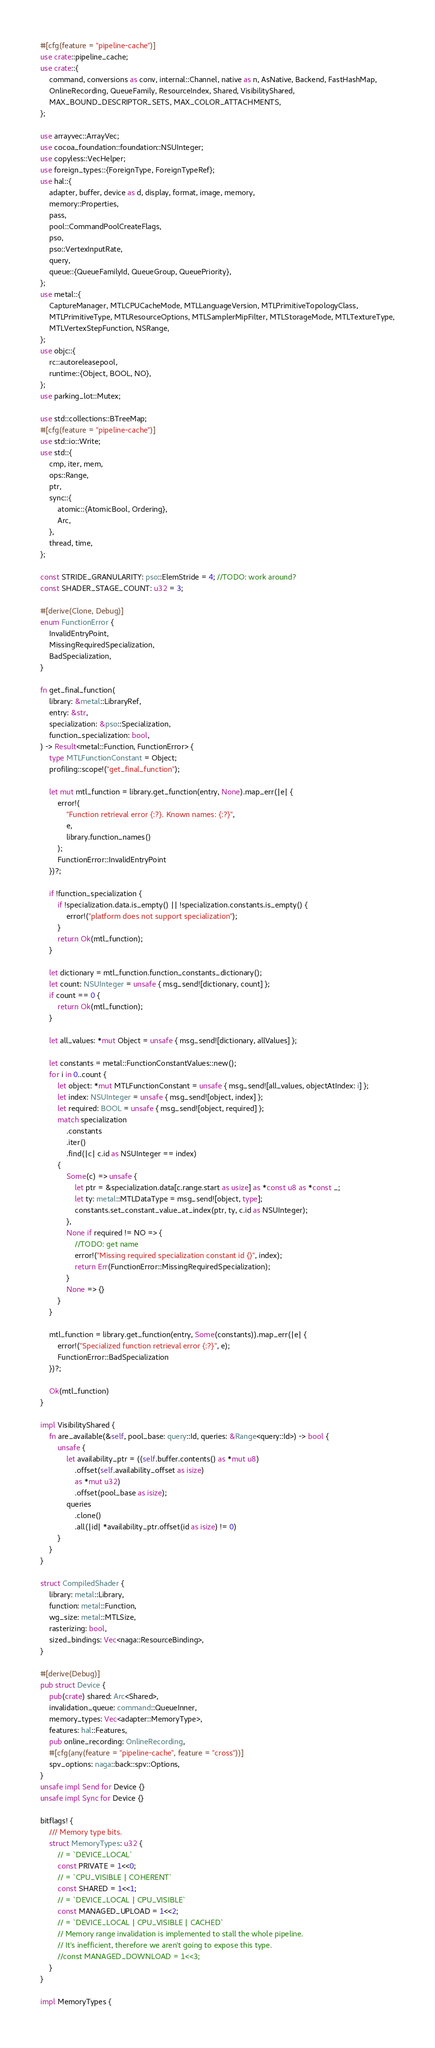Convert code to text. <code><loc_0><loc_0><loc_500><loc_500><_Rust_>#[cfg(feature = "pipeline-cache")]
use crate::pipeline_cache;
use crate::{
    command, conversions as conv, internal::Channel, native as n, AsNative, Backend, FastHashMap,
    OnlineRecording, QueueFamily, ResourceIndex, Shared, VisibilityShared,
    MAX_BOUND_DESCRIPTOR_SETS, MAX_COLOR_ATTACHMENTS,
};

use arrayvec::ArrayVec;
use cocoa_foundation::foundation::NSUInteger;
use copyless::VecHelper;
use foreign_types::{ForeignType, ForeignTypeRef};
use hal::{
    adapter, buffer, device as d, display, format, image, memory,
    memory::Properties,
    pass,
    pool::CommandPoolCreateFlags,
    pso,
    pso::VertexInputRate,
    query,
    queue::{QueueFamilyId, QueueGroup, QueuePriority},
};
use metal::{
    CaptureManager, MTLCPUCacheMode, MTLLanguageVersion, MTLPrimitiveTopologyClass,
    MTLPrimitiveType, MTLResourceOptions, MTLSamplerMipFilter, MTLStorageMode, MTLTextureType,
    MTLVertexStepFunction, NSRange,
};
use objc::{
    rc::autoreleasepool,
    runtime::{Object, BOOL, NO},
};
use parking_lot::Mutex;

use std::collections::BTreeMap;
#[cfg(feature = "pipeline-cache")]
use std::io::Write;
use std::{
    cmp, iter, mem,
    ops::Range,
    ptr,
    sync::{
        atomic::{AtomicBool, Ordering},
        Arc,
    },
    thread, time,
};

const STRIDE_GRANULARITY: pso::ElemStride = 4; //TODO: work around?
const SHADER_STAGE_COUNT: u32 = 3;

#[derive(Clone, Debug)]
enum FunctionError {
    InvalidEntryPoint,
    MissingRequiredSpecialization,
    BadSpecialization,
}

fn get_final_function(
    library: &metal::LibraryRef,
    entry: &str,
    specialization: &pso::Specialization,
    function_specialization: bool,
) -> Result<metal::Function, FunctionError> {
    type MTLFunctionConstant = Object;
    profiling::scope!("get_final_function");

    let mut mtl_function = library.get_function(entry, None).map_err(|e| {
        error!(
            "Function retrieval error {:?}. Known names: {:?}",
            e,
            library.function_names()
        );
        FunctionError::InvalidEntryPoint
    })?;

    if !function_specialization {
        if !specialization.data.is_empty() || !specialization.constants.is_empty() {
            error!("platform does not support specialization");
        }
        return Ok(mtl_function);
    }

    let dictionary = mtl_function.function_constants_dictionary();
    let count: NSUInteger = unsafe { msg_send![dictionary, count] };
    if count == 0 {
        return Ok(mtl_function);
    }

    let all_values: *mut Object = unsafe { msg_send![dictionary, allValues] };

    let constants = metal::FunctionConstantValues::new();
    for i in 0..count {
        let object: *mut MTLFunctionConstant = unsafe { msg_send![all_values, objectAtIndex: i] };
        let index: NSUInteger = unsafe { msg_send![object, index] };
        let required: BOOL = unsafe { msg_send![object, required] };
        match specialization
            .constants
            .iter()
            .find(|c| c.id as NSUInteger == index)
        {
            Some(c) => unsafe {
                let ptr = &specialization.data[c.range.start as usize] as *const u8 as *const _;
                let ty: metal::MTLDataType = msg_send![object, type];
                constants.set_constant_value_at_index(ptr, ty, c.id as NSUInteger);
            },
            None if required != NO => {
                //TODO: get name
                error!("Missing required specialization constant id {}", index);
                return Err(FunctionError::MissingRequiredSpecialization);
            }
            None => {}
        }
    }

    mtl_function = library.get_function(entry, Some(constants)).map_err(|e| {
        error!("Specialized function retrieval error {:?}", e);
        FunctionError::BadSpecialization
    })?;

    Ok(mtl_function)
}

impl VisibilityShared {
    fn are_available(&self, pool_base: query::Id, queries: &Range<query::Id>) -> bool {
        unsafe {
            let availability_ptr = ((self.buffer.contents() as *mut u8)
                .offset(self.availability_offset as isize)
                as *mut u32)
                .offset(pool_base as isize);
            queries
                .clone()
                .all(|id| *availability_ptr.offset(id as isize) != 0)
        }
    }
}

struct CompiledShader {
    library: metal::Library,
    function: metal::Function,
    wg_size: metal::MTLSize,
    rasterizing: bool,
    sized_bindings: Vec<naga::ResourceBinding>,
}

#[derive(Debug)]
pub struct Device {
    pub(crate) shared: Arc<Shared>,
    invalidation_queue: command::QueueInner,
    memory_types: Vec<adapter::MemoryType>,
    features: hal::Features,
    pub online_recording: OnlineRecording,
    #[cfg(any(feature = "pipeline-cache", feature = "cross"))]
    spv_options: naga::back::spv::Options,
}
unsafe impl Send for Device {}
unsafe impl Sync for Device {}

bitflags! {
    /// Memory type bits.
    struct MemoryTypes: u32 {
        // = `DEVICE_LOCAL`
        const PRIVATE = 1<<0;
        // = `CPU_VISIBLE | COHERENT`
        const SHARED = 1<<1;
        // = `DEVICE_LOCAL | CPU_VISIBLE`
        const MANAGED_UPLOAD = 1<<2;
        // = `DEVICE_LOCAL | CPU_VISIBLE | CACHED`
        // Memory range invalidation is implemented to stall the whole pipeline.
        // It's inefficient, therefore we aren't going to expose this type.
        //const MANAGED_DOWNLOAD = 1<<3;
    }
}

impl MemoryTypes {</code> 